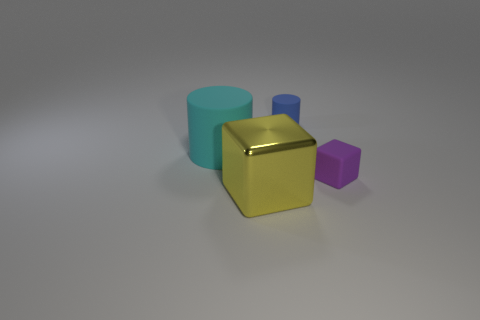How many matte things have the same shape as the large yellow metal object?
Your answer should be compact. 1. What is the material of the other small purple thing that is the same shape as the shiny object?
Ensure brevity in your answer.  Rubber. How many matte things are large yellow cubes or blue cylinders?
Your response must be concise. 1. Is the purple cube made of the same material as the tiny blue cylinder?
Keep it short and to the point. Yes. What material is the cylinder that is in front of the tiny matte thing behind the big cyan object?
Your answer should be compact. Rubber. What number of small objects are cyan rubber things or cubes?
Your answer should be compact. 1. The blue cylinder is what size?
Offer a terse response. Small. Are there more cyan cylinders that are behind the purple thing than purple matte cylinders?
Give a very brief answer. Yes. Are there an equal number of tiny purple things that are in front of the small blue object and blue objects that are in front of the yellow metal cube?
Provide a short and direct response. No. The object that is in front of the big matte thing and right of the metal cube is what color?
Keep it short and to the point. Purple. 